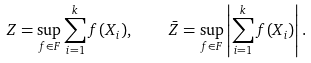Convert formula to latex. <formula><loc_0><loc_0><loc_500><loc_500>Z = \sup _ { f \in F } \sum _ { i = 1 } ^ { k } f ( X _ { i } ) , \quad \bar { Z } = \sup _ { f \in F } \left | \sum _ { i = 1 } ^ { k } f ( X _ { i } ) \right | .</formula> 